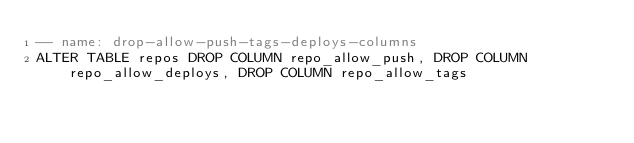<code> <loc_0><loc_0><loc_500><loc_500><_SQL_>-- name: drop-allow-push-tags-deploys-columns
ALTER TABLE repos DROP COLUMN repo_allow_push, DROP COLUMN repo_allow_deploys, DROP COLUMN repo_allow_tags
</code> 